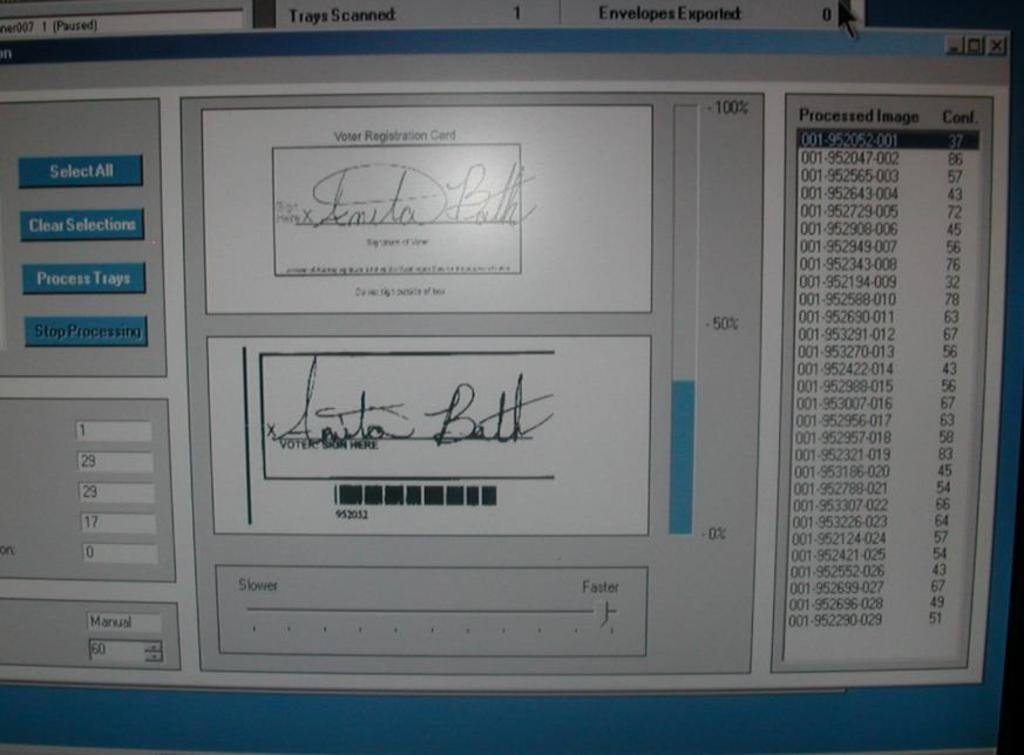<image>
Relay a brief, clear account of the picture shown. A computer screen comparing the signature on a Voter Registration Card with that of the voter. 